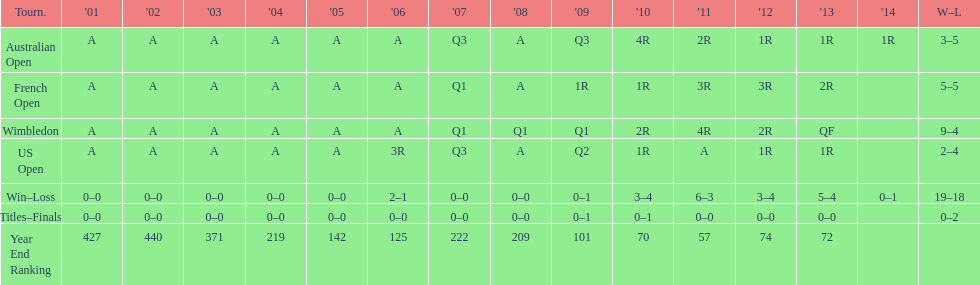In which years were there only 1 loss? 2006, 2009, 2014. 